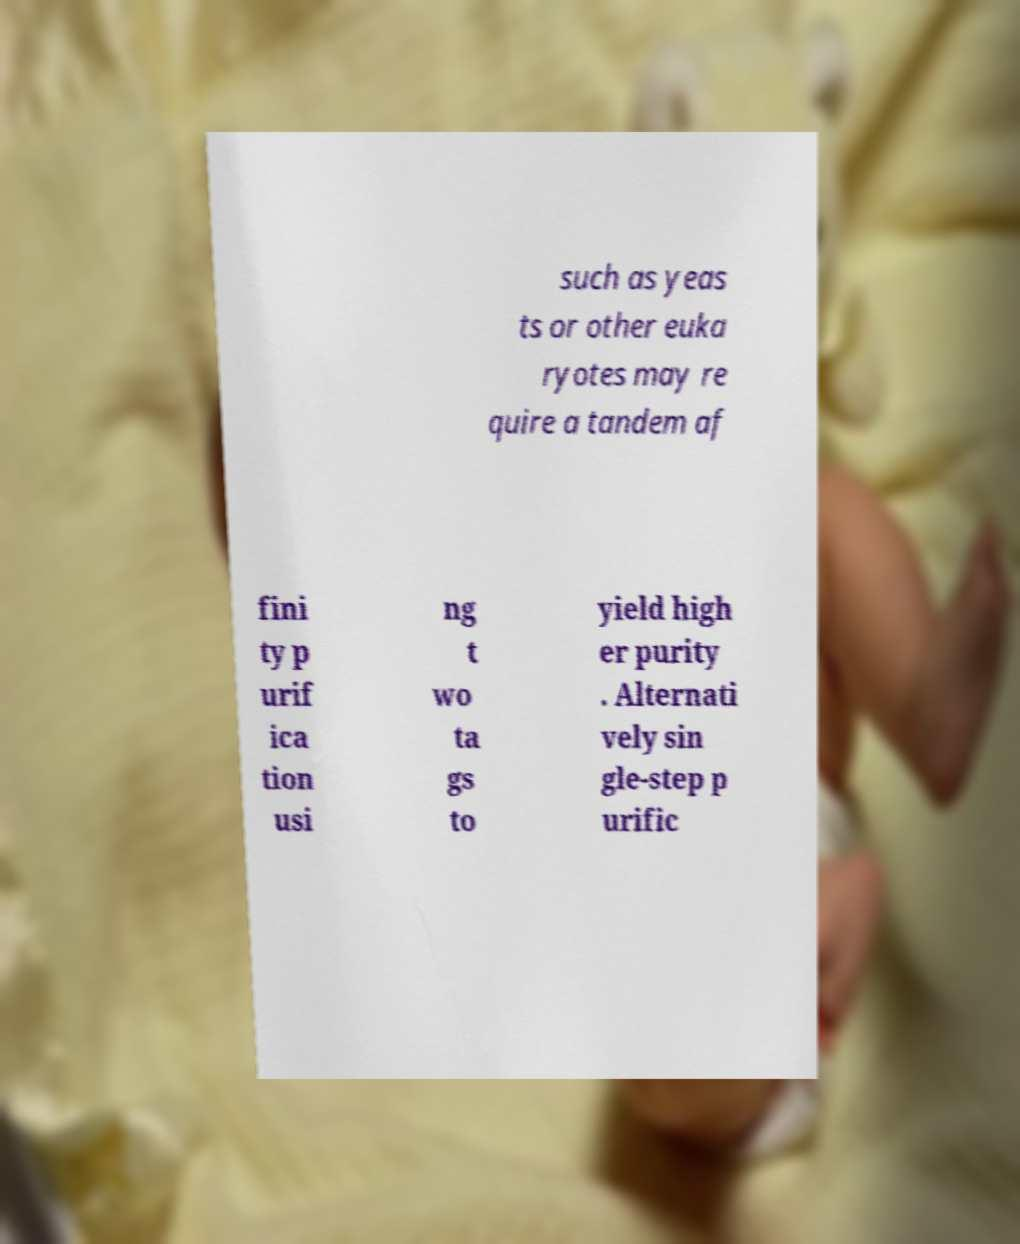Can you read and provide the text displayed in the image?This photo seems to have some interesting text. Can you extract and type it out for me? such as yeas ts or other euka ryotes may re quire a tandem af fini ty p urif ica tion usi ng t wo ta gs to yield high er purity . Alternati vely sin gle-step p urific 